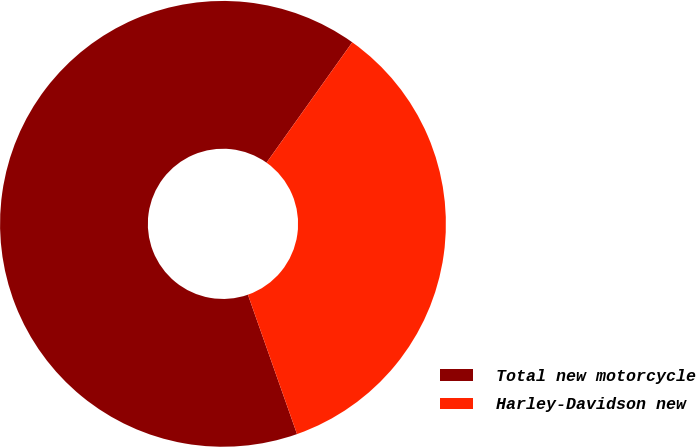<chart> <loc_0><loc_0><loc_500><loc_500><pie_chart><fcel>Total new motorcycle<fcel>Harley-Davidson new<nl><fcel>65.24%<fcel>34.76%<nl></chart> 